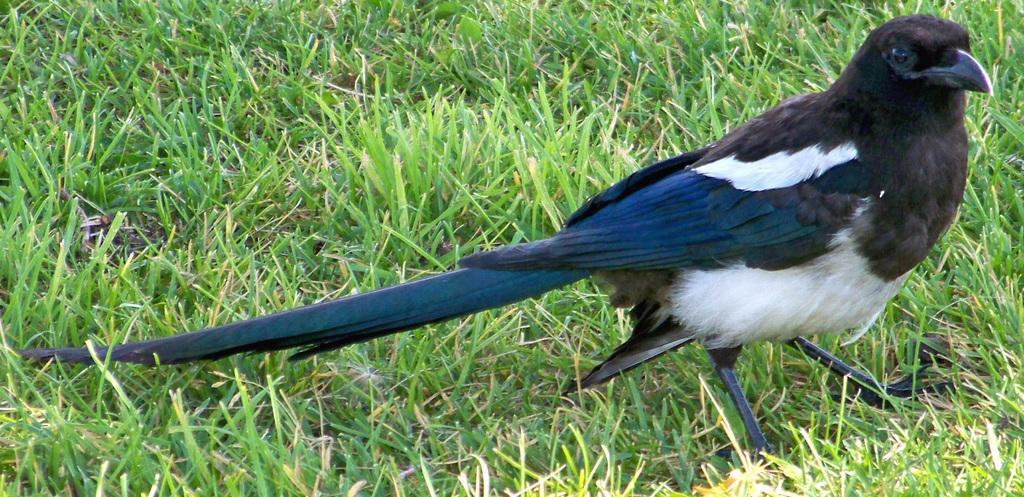Describe this image in one or two sentences. In this image, I can see a bird standing. This is the grass, which is green in color. 